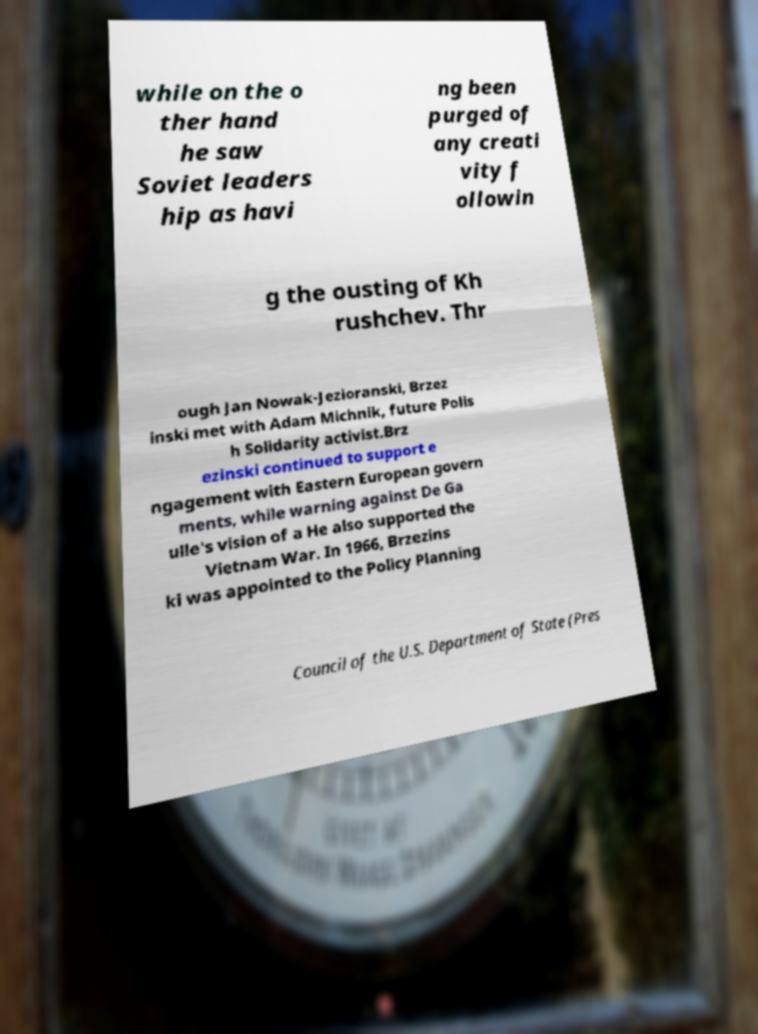Can you accurately transcribe the text from the provided image for me? while on the o ther hand he saw Soviet leaders hip as havi ng been purged of any creati vity f ollowin g the ousting of Kh rushchev. Thr ough Jan Nowak-Jezioranski, Brzez inski met with Adam Michnik, future Polis h Solidarity activist.Brz ezinski continued to support e ngagement with Eastern European govern ments, while warning against De Ga ulle's vision of a He also supported the Vietnam War. In 1966, Brzezins ki was appointed to the Policy Planning Council of the U.S. Department of State (Pres 